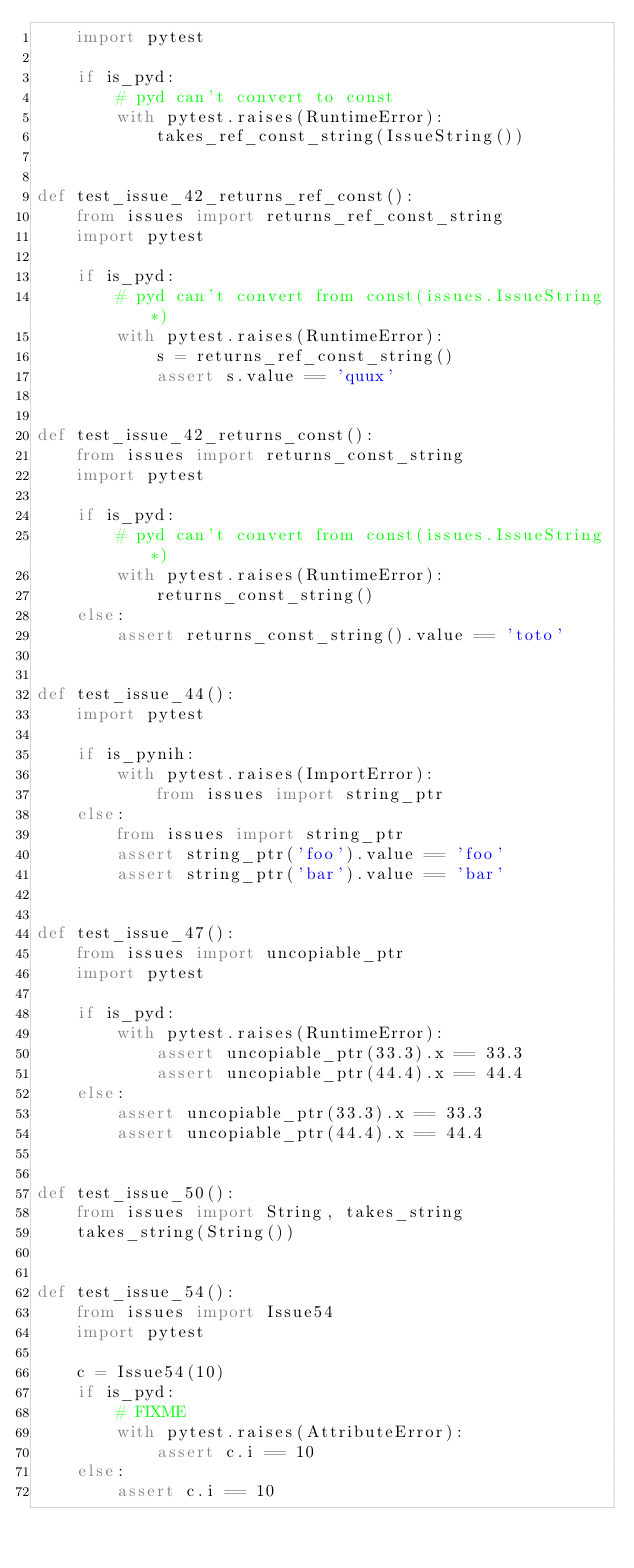<code> <loc_0><loc_0><loc_500><loc_500><_Python_>    import pytest

    if is_pyd:
        # pyd can't convert to const
        with pytest.raises(RuntimeError):
            takes_ref_const_string(IssueString())


def test_issue_42_returns_ref_const():
    from issues import returns_ref_const_string
    import pytest

    if is_pyd:
        # pyd can't convert from const(issues.IssueString*)
        with pytest.raises(RuntimeError):
            s = returns_ref_const_string()
            assert s.value == 'quux'


def test_issue_42_returns_const():
    from issues import returns_const_string
    import pytest

    if is_pyd:
        # pyd can't convert from const(issues.IssueString*)
        with pytest.raises(RuntimeError):
            returns_const_string()
    else:
        assert returns_const_string().value == 'toto'


def test_issue_44():
    import pytest

    if is_pynih:
        with pytest.raises(ImportError):
            from issues import string_ptr
    else:
        from issues import string_ptr
        assert string_ptr('foo').value == 'foo'
        assert string_ptr('bar').value == 'bar'


def test_issue_47():
    from issues import uncopiable_ptr
    import pytest

    if is_pyd:
        with pytest.raises(RuntimeError):
            assert uncopiable_ptr(33.3).x == 33.3
            assert uncopiable_ptr(44.4).x == 44.4
    else:
        assert uncopiable_ptr(33.3).x == 33.3
        assert uncopiable_ptr(44.4).x == 44.4


def test_issue_50():
    from issues import String, takes_string
    takes_string(String())


def test_issue_54():
    from issues import Issue54
    import pytest

    c = Issue54(10)
    if is_pyd:
        # FIXME
        with pytest.raises(AttributeError):
            assert c.i == 10
    else:
        assert c.i == 10
</code> 